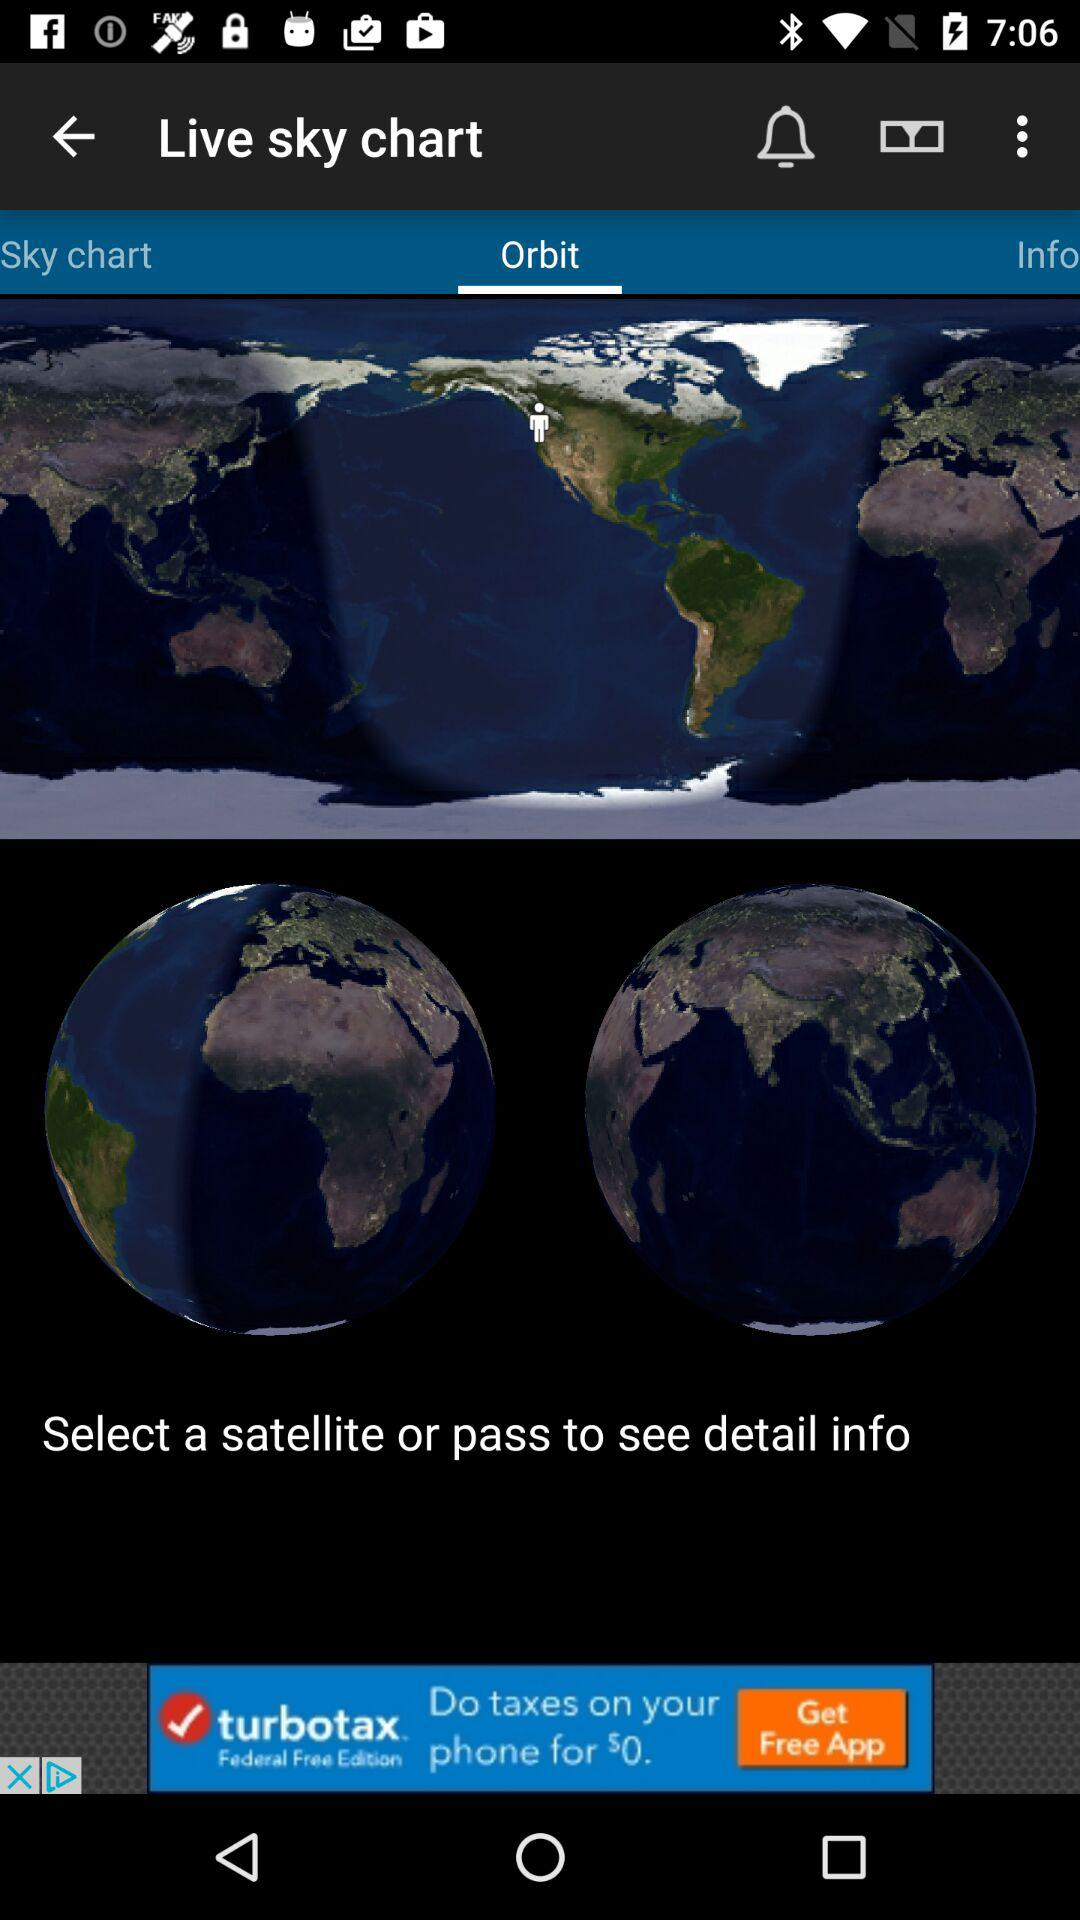Which tab is selected? The selected tab is "Orbit". 